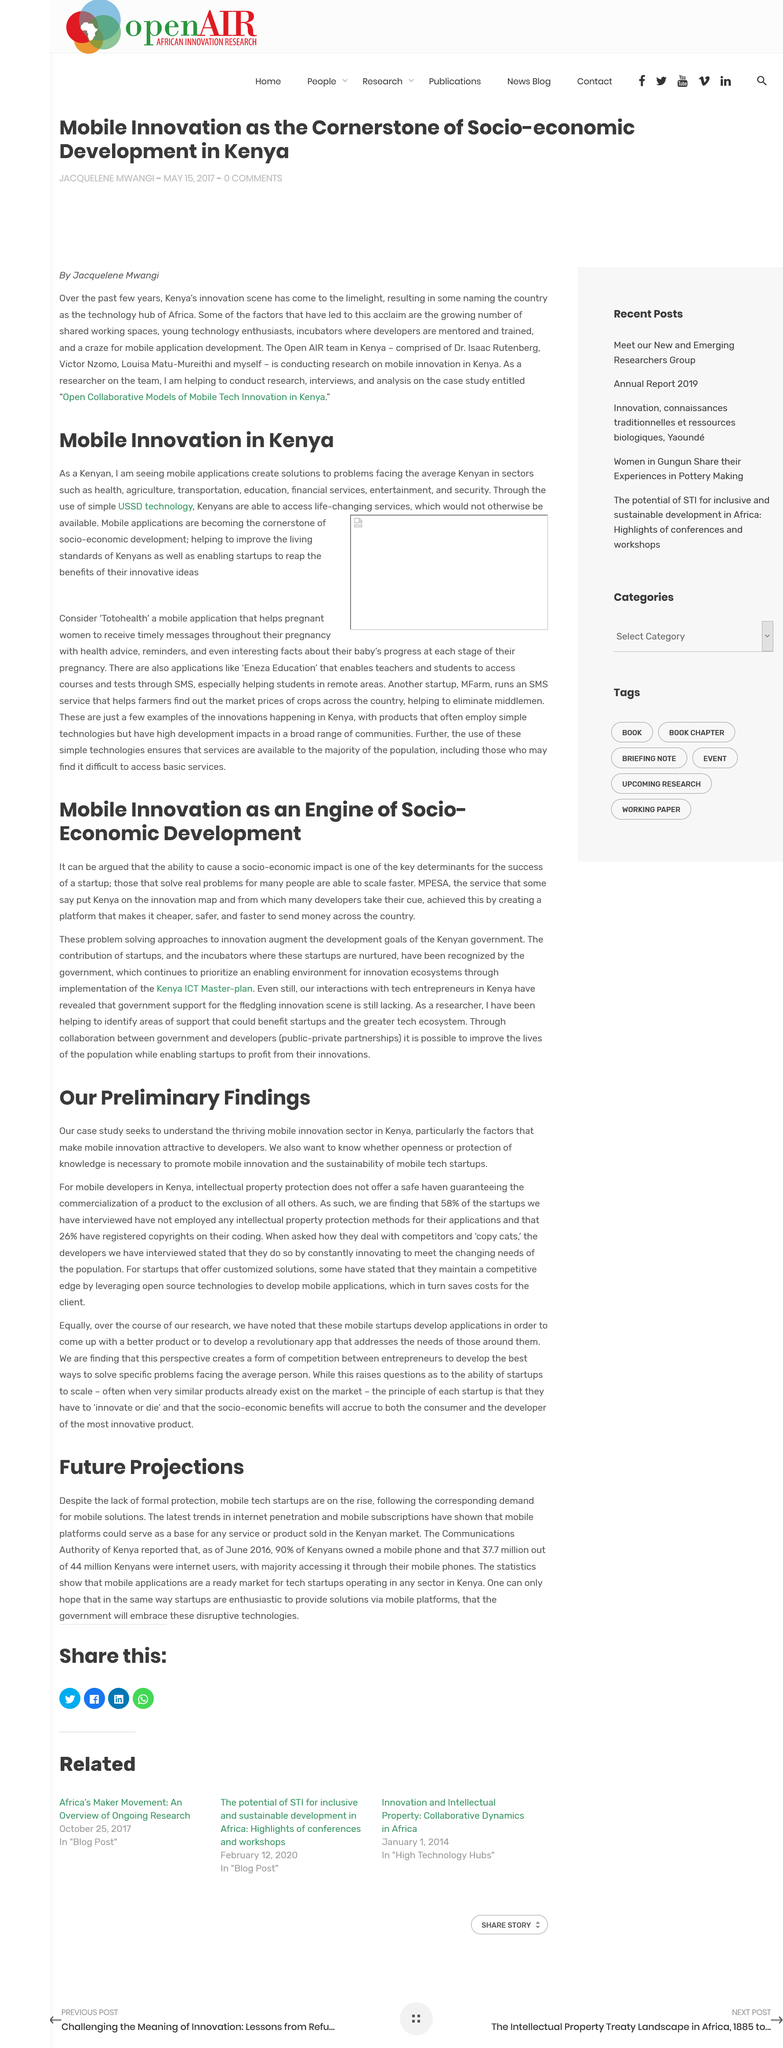Highlight a few significant elements in this photo. The three-letter abbreviation "ICT" is part of the title of the Kenya Master-plan. This article explores mobile innovation as a driving force for socio-economic development, as stated in the title. Yes, there are many startups in Kenya due to the widespread use of mobile applications in the country. Kenya has widespread coverage of 4G and 3G networks in most areas of the country, providing access to high-speed internet. The study is situated in Kenya. 